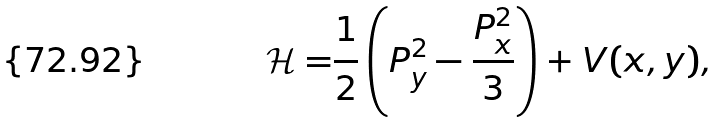<formula> <loc_0><loc_0><loc_500><loc_500>\mathcal { H = } \frac { 1 } { 2 } \left ( P _ { y } ^ { 2 } - \frac { P _ { x } ^ { 2 } } { 3 } \right ) + V ( x , y ) ,</formula> 